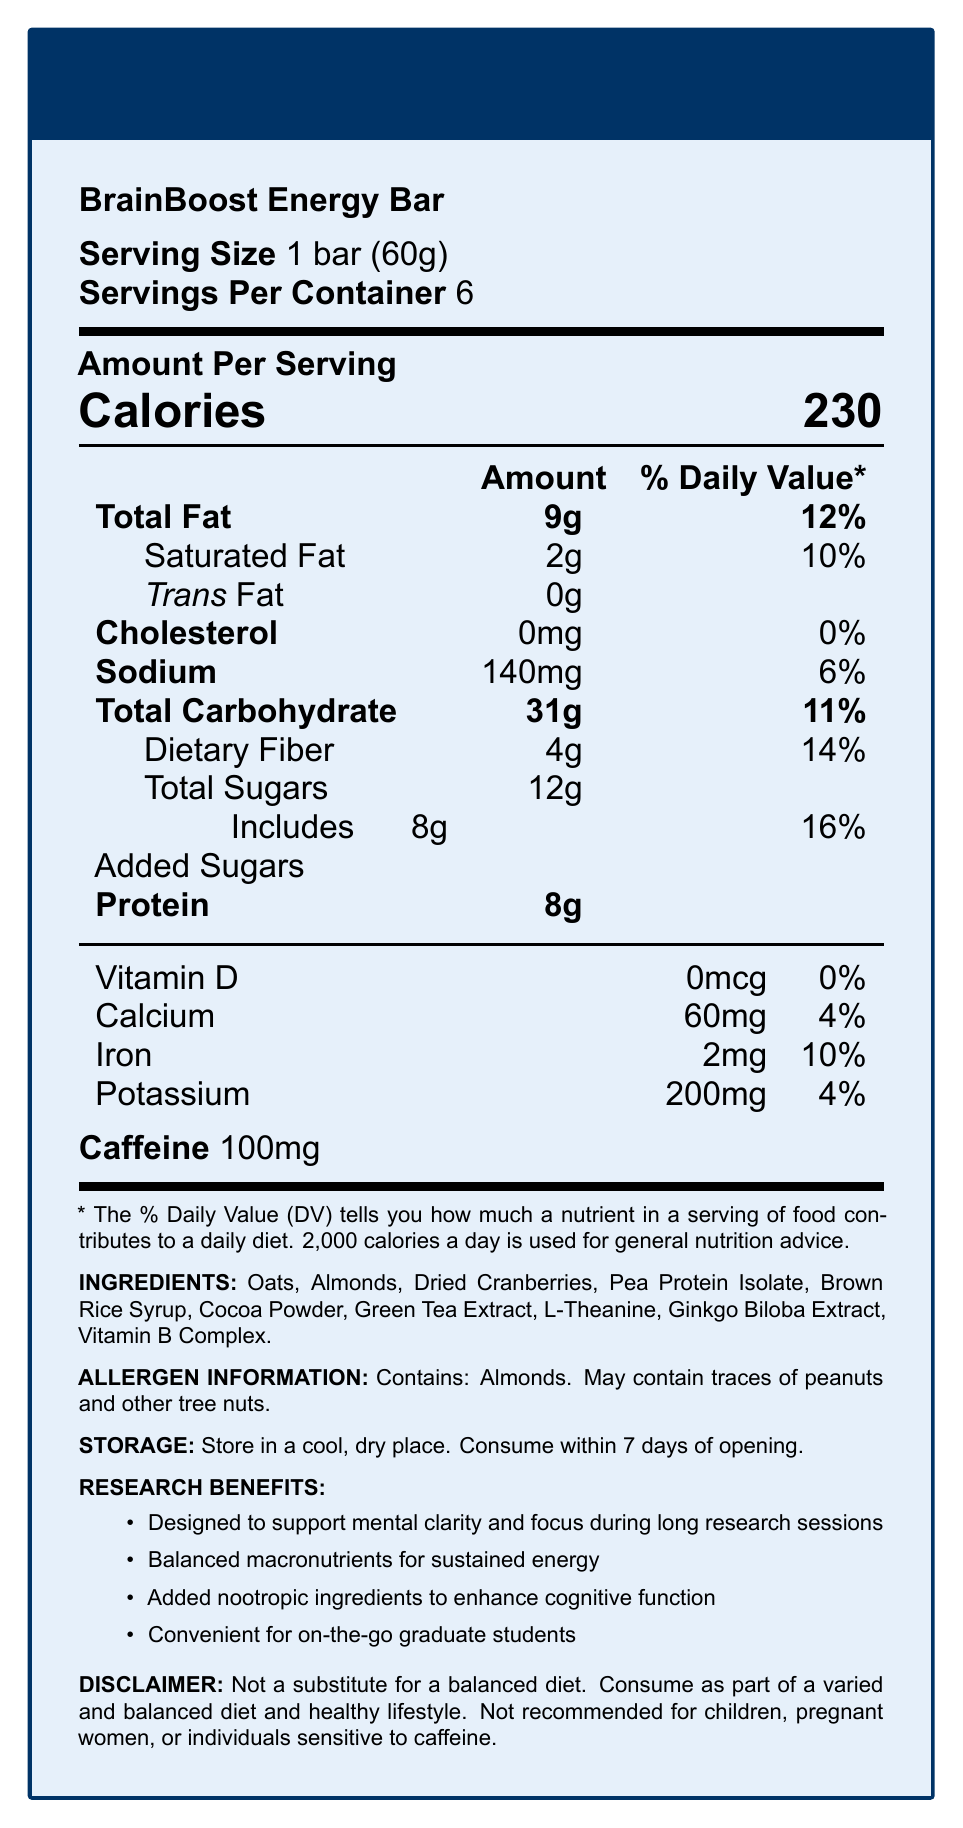what is the serving size of the BrainBoost Energy Bar? The serving size is explicitly stated as "1 bar (60g)" in the document.
Answer: 1 bar (60g) How many calories are in one serving of the BrainBoost Energy Bar? The document lists 230 calories under "Amount Per Serving".
Answer: 230 What percentage of the daily value is provided by the dietary fiber in one serving? The daily value percentage for dietary fiber is shown as 14% in the document.
Answer: 14% What is the total sugar content in one serving of the BrainBoost Energy Bar? The total sugar content, including added sugars, amounts to 12g, as stated.
Answer: 12g How much protein is in each bar? The protein content per serving is labeled as 8g.
Answer: 8g Which ingredient ensures the product contains caffeine? A. Green Tea Extract B. Almonds C. Cocoa Powder D. Dried Cranberries The document lists caffeine specifically, and Green Tea Extract is known for containing caffeine.
Answer: A The BrainBoost Energy Bar is most suitable for which of the following? A. Pregnant Women B. Individuals Sensitive to Caffeine C. On-the-go Graduate Students The document's "Research Benefits" section mentions convenience for on-the-go graduate students.
Answer: C Is this product recommended for children? The document explicitly states that this product is not recommended for children in the disclaimer.
Answer: No What are the special ingredients included to enhance cognitive function? These ingredients are listed under additional ingredients and are known nootropics.
Answer: Green Tea Extract, L-Theanine, Ginkgo Biloba Extract, Vitamin B Complex Summarize the primary purpose and content of the BrainBoost Energy Bar's Nutrition Facts Label. The main idea of the document is to provide a comprehensive overview of the nutritional and functional benefits of the BrainBoost Energy Bar, aimed at enhancing mental clarity and focus for graduate students during research.
Answer: The BrainBoost Energy Bar's Nutrition Facts Label provides detailed nutritional information for a single serving of the bar, highlighting its calories, fats, carbohydrates, protein, and vitamins. The label also includes specific nootropic ingredients to boost cognitive function, allergen information, storage instructions, and a disclaimer regarding its use. Can we find information about the pricing of the BrainBoost Energy Bar from the nutrition label? The document does not provide any information about the pricing of the BrainBoost Energy Bar. It only covers nutritional data and ingredients.
Answer: Not enough information 